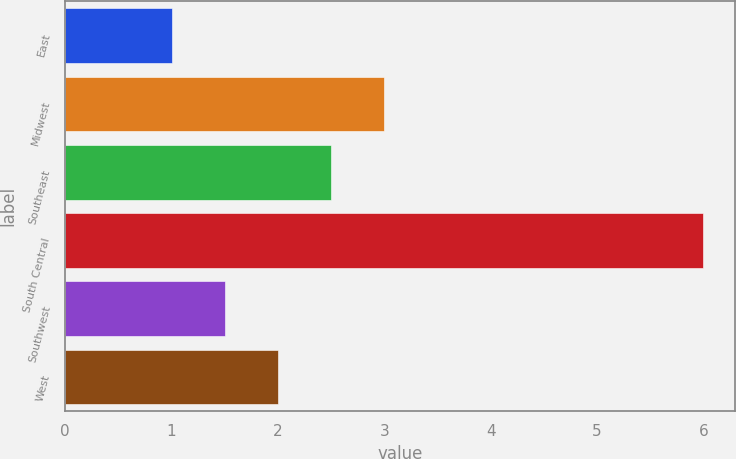Convert chart to OTSL. <chart><loc_0><loc_0><loc_500><loc_500><bar_chart><fcel>East<fcel>Midwest<fcel>Southeast<fcel>South Central<fcel>Southwest<fcel>West<nl><fcel>1<fcel>3<fcel>2.5<fcel>6<fcel>1.5<fcel>2<nl></chart> 